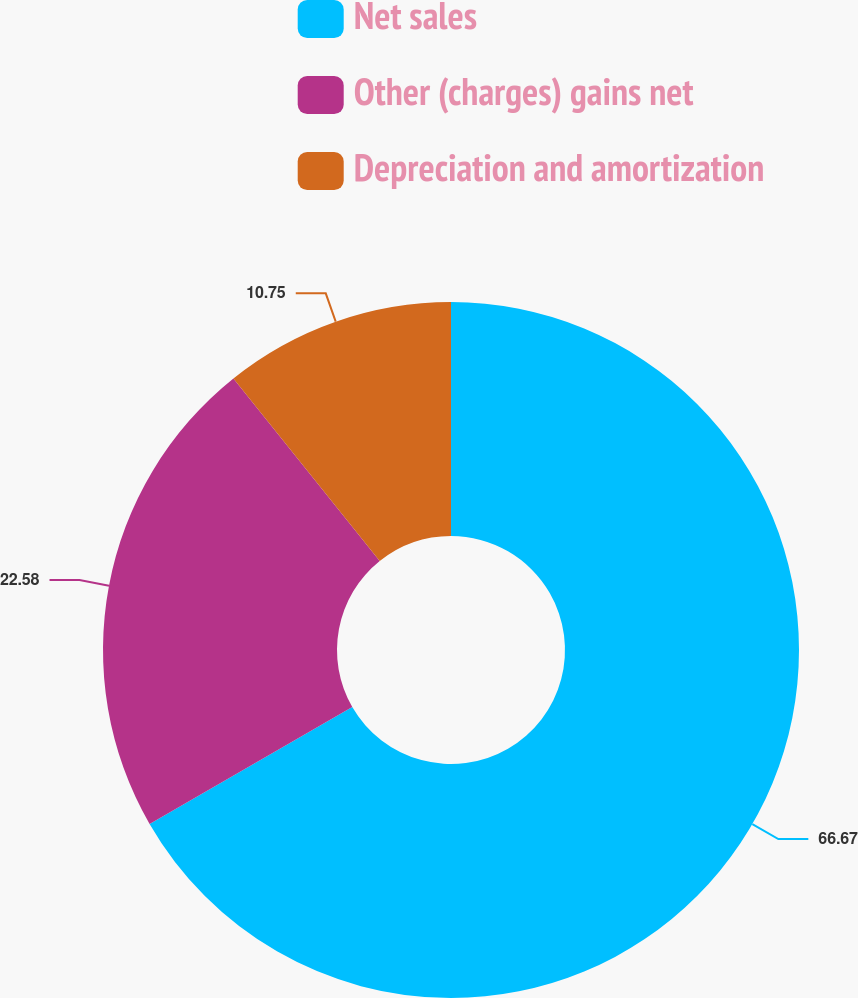<chart> <loc_0><loc_0><loc_500><loc_500><pie_chart><fcel>Net sales<fcel>Other (charges) gains net<fcel>Depreciation and amortization<nl><fcel>66.67%<fcel>22.58%<fcel>10.75%<nl></chart> 